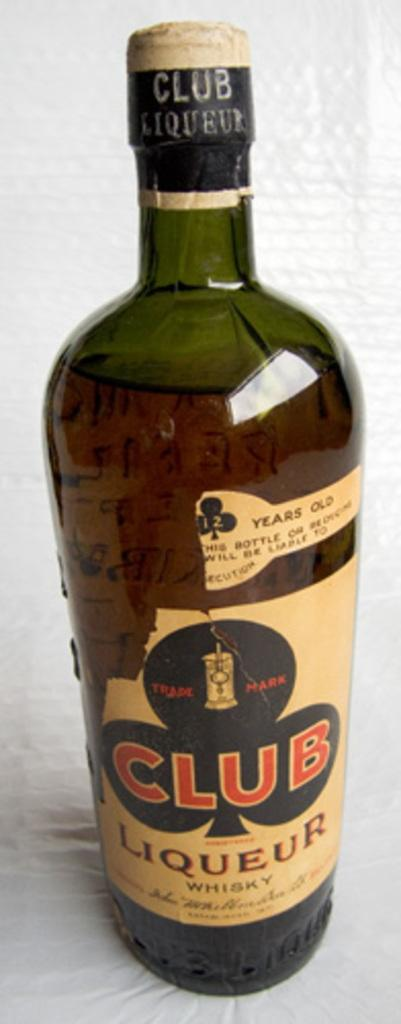What object can be seen in the image? There is a bottle in the image. What is on the bottle? The bottle has a sticker on it. What is inside the bottle? There is a drink inside the bottle. What color is the pencil that is being used to draw a cloud on the bottle? There is no pencil or drawing of a cloud on the bottle in the image. 